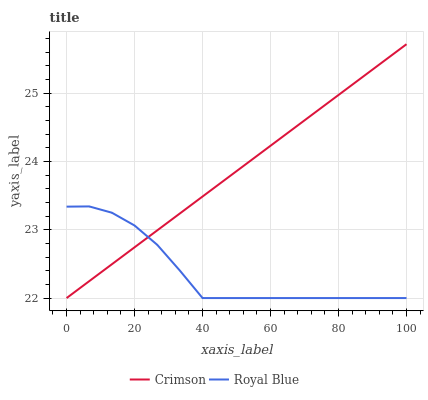Does Royal Blue have the minimum area under the curve?
Answer yes or no. Yes. Does Crimson have the maximum area under the curve?
Answer yes or no. Yes. Does Royal Blue have the maximum area under the curve?
Answer yes or no. No. Is Crimson the smoothest?
Answer yes or no. Yes. Is Royal Blue the roughest?
Answer yes or no. Yes. Is Royal Blue the smoothest?
Answer yes or no. No. Does Crimson have the lowest value?
Answer yes or no. Yes. Does Crimson have the highest value?
Answer yes or no. Yes. Does Royal Blue have the highest value?
Answer yes or no. No. Does Royal Blue intersect Crimson?
Answer yes or no. Yes. Is Royal Blue less than Crimson?
Answer yes or no. No. Is Royal Blue greater than Crimson?
Answer yes or no. No. 